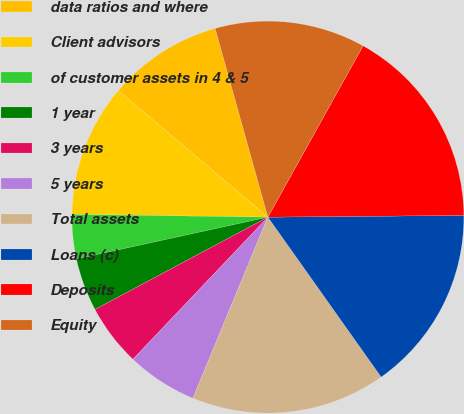<chart> <loc_0><loc_0><loc_500><loc_500><pie_chart><fcel>data ratios and where<fcel>Client advisors<fcel>of customer assets in 4 & 5<fcel>1 year<fcel>3 years<fcel>5 years<fcel>Total assets<fcel>Loans (c)<fcel>Deposits<fcel>Equity<nl><fcel>9.49%<fcel>10.95%<fcel>3.65%<fcel>4.38%<fcel>5.11%<fcel>5.84%<fcel>16.06%<fcel>15.33%<fcel>16.79%<fcel>12.41%<nl></chart> 